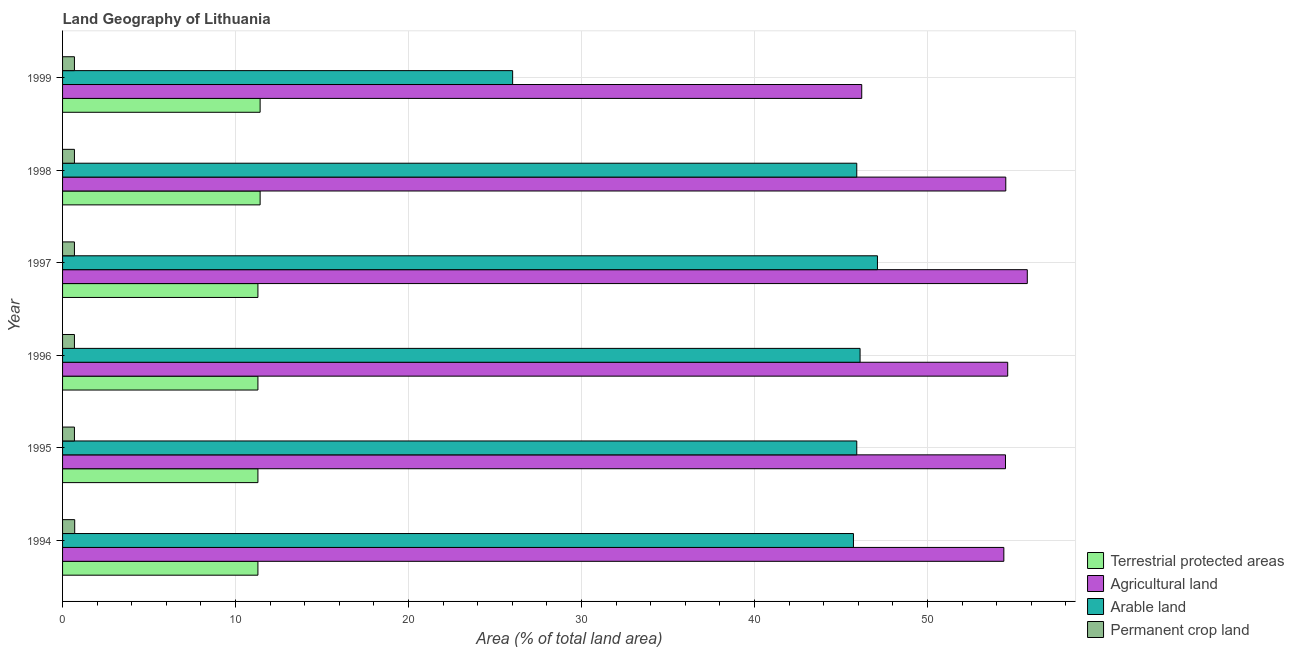How many groups of bars are there?
Offer a very short reply. 6. Are the number of bars on each tick of the Y-axis equal?
Your answer should be compact. Yes. What is the label of the 4th group of bars from the top?
Keep it short and to the point. 1996. In how many cases, is the number of bars for a given year not equal to the number of legend labels?
Ensure brevity in your answer.  0. What is the percentage of area under agricultural land in 1998?
Give a very brief answer. 54.53. Across all years, what is the maximum percentage of area under arable land?
Your answer should be compact. 47.11. Across all years, what is the minimum percentage of area under agricultural land?
Your response must be concise. 46.2. In which year was the percentage of area under permanent crop land maximum?
Keep it short and to the point. 1994. What is the total percentage of land under terrestrial protection in the graph?
Provide a succinct answer. 68.02. What is the difference between the percentage of area under agricultural land in 1997 and that in 1999?
Give a very brief answer. 9.57. What is the difference between the percentage of area under permanent crop land in 1995 and the percentage of area under agricultural land in 1999?
Make the answer very short. -45.52. What is the average percentage of area under agricultural land per year?
Offer a terse response. 53.35. In the year 1994, what is the difference between the percentage of area under permanent crop land and percentage of land under terrestrial protection?
Provide a succinct answer. -10.59. Is the difference between the percentage of land under terrestrial protection in 1995 and 1999 greater than the difference between the percentage of area under permanent crop land in 1995 and 1999?
Offer a very short reply. No. What is the difference between the highest and the second highest percentage of area under agricultural land?
Your answer should be very brief. 1.13. What is the difference between the highest and the lowest percentage of area under agricultural land?
Give a very brief answer. 9.57. Is it the case that in every year, the sum of the percentage of area under arable land and percentage of area under agricultural land is greater than the sum of percentage of land under terrestrial protection and percentage of area under permanent crop land?
Your answer should be very brief. Yes. What does the 3rd bar from the top in 1994 represents?
Your answer should be compact. Agricultural land. What does the 4th bar from the bottom in 1997 represents?
Provide a succinct answer. Permanent crop land. How many bars are there?
Provide a short and direct response. 24. Are all the bars in the graph horizontal?
Keep it short and to the point. Yes. What is the difference between two consecutive major ticks on the X-axis?
Provide a succinct answer. 10. Does the graph contain any zero values?
Your answer should be very brief. No. How many legend labels are there?
Provide a succinct answer. 4. What is the title of the graph?
Provide a short and direct response. Land Geography of Lithuania. Does "Primary education" appear as one of the legend labels in the graph?
Provide a short and direct response. No. What is the label or title of the X-axis?
Your answer should be compact. Area (% of total land area). What is the Area (% of total land area) in Terrestrial protected areas in 1994?
Offer a very short reply. 11.29. What is the Area (% of total land area) of Agricultural land in 1994?
Provide a succinct answer. 54.42. What is the Area (% of total land area) in Arable land in 1994?
Make the answer very short. 45.72. What is the Area (% of total land area) of Permanent crop land in 1994?
Keep it short and to the point. 0.7. What is the Area (% of total land area) of Terrestrial protected areas in 1995?
Provide a succinct answer. 11.29. What is the Area (% of total land area) in Agricultural land in 1995?
Provide a short and direct response. 54.51. What is the Area (% of total land area) in Arable land in 1995?
Provide a succinct answer. 45.92. What is the Area (% of total land area) in Permanent crop land in 1995?
Ensure brevity in your answer.  0.69. What is the Area (% of total land area) in Terrestrial protected areas in 1996?
Your answer should be compact. 11.29. What is the Area (% of total land area) in Agricultural land in 1996?
Your answer should be very brief. 54.64. What is the Area (% of total land area) in Arable land in 1996?
Give a very brief answer. 46.11. What is the Area (% of total land area) of Permanent crop land in 1996?
Provide a succinct answer. 0.69. What is the Area (% of total land area) of Terrestrial protected areas in 1997?
Give a very brief answer. 11.29. What is the Area (% of total land area) in Agricultural land in 1997?
Provide a short and direct response. 55.78. What is the Area (% of total land area) of Arable land in 1997?
Your answer should be compact. 47.11. What is the Area (% of total land area) in Permanent crop land in 1997?
Your answer should be very brief. 0.69. What is the Area (% of total land area) of Terrestrial protected areas in 1998?
Your answer should be compact. 11.42. What is the Area (% of total land area) in Agricultural land in 1998?
Provide a short and direct response. 54.53. What is the Area (% of total land area) in Arable land in 1998?
Give a very brief answer. 45.92. What is the Area (% of total land area) of Permanent crop land in 1998?
Your response must be concise. 0.69. What is the Area (% of total land area) of Terrestrial protected areas in 1999?
Ensure brevity in your answer.  11.42. What is the Area (% of total land area) of Agricultural land in 1999?
Offer a terse response. 46.2. What is the Area (% of total land area) of Arable land in 1999?
Make the answer very short. 26.02. What is the Area (% of total land area) in Permanent crop land in 1999?
Provide a succinct answer. 0.69. Across all years, what is the maximum Area (% of total land area) of Terrestrial protected areas?
Give a very brief answer. 11.42. Across all years, what is the maximum Area (% of total land area) in Agricultural land?
Provide a succinct answer. 55.78. Across all years, what is the maximum Area (% of total land area) in Arable land?
Provide a short and direct response. 47.11. Across all years, what is the maximum Area (% of total land area) in Permanent crop land?
Ensure brevity in your answer.  0.7. Across all years, what is the minimum Area (% of total land area) in Terrestrial protected areas?
Make the answer very short. 11.29. Across all years, what is the minimum Area (% of total land area) of Agricultural land?
Your response must be concise. 46.2. Across all years, what is the minimum Area (% of total land area) of Arable land?
Keep it short and to the point. 26.02. Across all years, what is the minimum Area (% of total land area) in Permanent crop land?
Keep it short and to the point. 0.69. What is the total Area (% of total land area) in Terrestrial protected areas in the graph?
Ensure brevity in your answer.  68.02. What is the total Area (% of total land area) of Agricultural land in the graph?
Ensure brevity in your answer.  320.09. What is the total Area (% of total land area) of Arable land in the graph?
Ensure brevity in your answer.  256.8. What is the total Area (% of total land area) in Permanent crop land in the graph?
Provide a succinct answer. 4.13. What is the difference between the Area (% of total land area) of Agricultural land in 1994 and that in 1995?
Provide a succinct answer. -0.1. What is the difference between the Area (% of total land area) in Arable land in 1994 and that in 1995?
Provide a succinct answer. -0.19. What is the difference between the Area (% of total land area) of Permanent crop land in 1994 and that in 1995?
Offer a very short reply. 0.02. What is the difference between the Area (% of total land area) in Agricultural land in 1994 and that in 1996?
Make the answer very short. -0.22. What is the difference between the Area (% of total land area) in Arable land in 1994 and that in 1996?
Offer a very short reply. -0.38. What is the difference between the Area (% of total land area) of Permanent crop land in 1994 and that in 1996?
Ensure brevity in your answer.  0.02. What is the difference between the Area (% of total land area) in Agricultural land in 1994 and that in 1997?
Your answer should be compact. -1.36. What is the difference between the Area (% of total land area) in Arable land in 1994 and that in 1997?
Keep it short and to the point. -1.39. What is the difference between the Area (% of total land area) of Permanent crop land in 1994 and that in 1997?
Offer a very short reply. 0.02. What is the difference between the Area (% of total land area) in Terrestrial protected areas in 1994 and that in 1998?
Your answer should be very brief. -0.13. What is the difference between the Area (% of total land area) in Agricultural land in 1994 and that in 1998?
Give a very brief answer. -0.11. What is the difference between the Area (% of total land area) of Arable land in 1994 and that in 1998?
Offer a terse response. -0.19. What is the difference between the Area (% of total land area) in Permanent crop land in 1994 and that in 1998?
Give a very brief answer. 0.02. What is the difference between the Area (% of total land area) of Terrestrial protected areas in 1994 and that in 1999?
Ensure brevity in your answer.  -0.13. What is the difference between the Area (% of total land area) of Agricultural land in 1994 and that in 1999?
Offer a terse response. 8.22. What is the difference between the Area (% of total land area) in Arable land in 1994 and that in 1999?
Keep it short and to the point. 19.7. What is the difference between the Area (% of total land area) in Permanent crop land in 1994 and that in 1999?
Offer a very short reply. 0.02. What is the difference between the Area (% of total land area) in Agricultural land in 1995 and that in 1996?
Provide a short and direct response. -0.13. What is the difference between the Area (% of total land area) of Arable land in 1995 and that in 1996?
Give a very brief answer. -0.19. What is the difference between the Area (% of total land area) in Agricultural land in 1995 and that in 1997?
Make the answer very short. -1.26. What is the difference between the Area (% of total land area) in Arable land in 1995 and that in 1997?
Give a very brief answer. -1.2. What is the difference between the Area (% of total land area) in Terrestrial protected areas in 1995 and that in 1998?
Your answer should be very brief. -0.13. What is the difference between the Area (% of total land area) in Agricultural land in 1995 and that in 1998?
Give a very brief answer. -0.02. What is the difference between the Area (% of total land area) of Permanent crop land in 1995 and that in 1998?
Offer a very short reply. 0. What is the difference between the Area (% of total land area) of Terrestrial protected areas in 1995 and that in 1999?
Give a very brief answer. -0.13. What is the difference between the Area (% of total land area) in Agricultural land in 1995 and that in 1999?
Your answer should be compact. 8.31. What is the difference between the Area (% of total land area) of Arable land in 1995 and that in 1999?
Offer a terse response. 19.89. What is the difference between the Area (% of total land area) in Agricultural land in 1996 and that in 1997?
Your answer should be very brief. -1.13. What is the difference between the Area (% of total land area) in Arable land in 1996 and that in 1997?
Ensure brevity in your answer.  -1.01. What is the difference between the Area (% of total land area) of Permanent crop land in 1996 and that in 1997?
Offer a terse response. 0. What is the difference between the Area (% of total land area) of Terrestrial protected areas in 1996 and that in 1998?
Your answer should be very brief. -0.13. What is the difference between the Area (% of total land area) in Agricultural land in 1996 and that in 1998?
Offer a terse response. 0.11. What is the difference between the Area (% of total land area) of Arable land in 1996 and that in 1998?
Provide a short and direct response. 0.19. What is the difference between the Area (% of total land area) in Terrestrial protected areas in 1996 and that in 1999?
Ensure brevity in your answer.  -0.13. What is the difference between the Area (% of total land area) in Agricultural land in 1996 and that in 1999?
Your answer should be compact. 8.44. What is the difference between the Area (% of total land area) of Arable land in 1996 and that in 1999?
Your answer should be compact. 20.09. What is the difference between the Area (% of total land area) in Permanent crop land in 1996 and that in 1999?
Ensure brevity in your answer.  0. What is the difference between the Area (% of total land area) of Terrestrial protected areas in 1997 and that in 1998?
Provide a succinct answer. -0.13. What is the difference between the Area (% of total land area) in Agricultural land in 1997 and that in 1998?
Your answer should be very brief. 1.24. What is the difference between the Area (% of total land area) in Arable land in 1997 and that in 1998?
Provide a succinct answer. 1.2. What is the difference between the Area (% of total land area) in Terrestrial protected areas in 1997 and that in 1999?
Offer a very short reply. -0.13. What is the difference between the Area (% of total land area) of Agricultural land in 1997 and that in 1999?
Your answer should be very brief. 9.57. What is the difference between the Area (% of total land area) of Arable land in 1997 and that in 1999?
Provide a short and direct response. 21.09. What is the difference between the Area (% of total land area) in Permanent crop land in 1997 and that in 1999?
Offer a very short reply. 0. What is the difference between the Area (% of total land area) of Terrestrial protected areas in 1998 and that in 1999?
Ensure brevity in your answer.  -0. What is the difference between the Area (% of total land area) in Agricultural land in 1998 and that in 1999?
Provide a succinct answer. 8.33. What is the difference between the Area (% of total land area) of Arable land in 1998 and that in 1999?
Ensure brevity in your answer.  19.89. What is the difference between the Area (% of total land area) in Terrestrial protected areas in 1994 and the Area (% of total land area) in Agricultural land in 1995?
Your answer should be very brief. -43.22. What is the difference between the Area (% of total land area) in Terrestrial protected areas in 1994 and the Area (% of total land area) in Arable land in 1995?
Your answer should be compact. -34.62. What is the difference between the Area (% of total land area) of Terrestrial protected areas in 1994 and the Area (% of total land area) of Permanent crop land in 1995?
Offer a terse response. 10.61. What is the difference between the Area (% of total land area) of Agricultural land in 1994 and the Area (% of total land area) of Arable land in 1995?
Your answer should be compact. 8.5. What is the difference between the Area (% of total land area) in Agricultural land in 1994 and the Area (% of total land area) in Permanent crop land in 1995?
Ensure brevity in your answer.  53.73. What is the difference between the Area (% of total land area) in Arable land in 1994 and the Area (% of total land area) in Permanent crop land in 1995?
Your answer should be compact. 45.04. What is the difference between the Area (% of total land area) of Terrestrial protected areas in 1994 and the Area (% of total land area) of Agricultural land in 1996?
Ensure brevity in your answer.  -43.35. What is the difference between the Area (% of total land area) of Terrestrial protected areas in 1994 and the Area (% of total land area) of Arable land in 1996?
Your response must be concise. -34.81. What is the difference between the Area (% of total land area) in Terrestrial protected areas in 1994 and the Area (% of total land area) in Permanent crop land in 1996?
Ensure brevity in your answer.  10.61. What is the difference between the Area (% of total land area) in Agricultural land in 1994 and the Area (% of total land area) in Arable land in 1996?
Your answer should be very brief. 8.31. What is the difference between the Area (% of total land area) of Agricultural land in 1994 and the Area (% of total land area) of Permanent crop land in 1996?
Provide a short and direct response. 53.73. What is the difference between the Area (% of total land area) in Arable land in 1994 and the Area (% of total land area) in Permanent crop land in 1996?
Provide a short and direct response. 45.04. What is the difference between the Area (% of total land area) of Terrestrial protected areas in 1994 and the Area (% of total land area) of Agricultural land in 1997?
Ensure brevity in your answer.  -44.48. What is the difference between the Area (% of total land area) of Terrestrial protected areas in 1994 and the Area (% of total land area) of Arable land in 1997?
Offer a very short reply. -35.82. What is the difference between the Area (% of total land area) of Terrestrial protected areas in 1994 and the Area (% of total land area) of Permanent crop land in 1997?
Offer a terse response. 10.61. What is the difference between the Area (% of total land area) of Agricultural land in 1994 and the Area (% of total land area) of Arable land in 1997?
Your answer should be compact. 7.31. What is the difference between the Area (% of total land area) of Agricultural land in 1994 and the Area (% of total land area) of Permanent crop land in 1997?
Your answer should be compact. 53.73. What is the difference between the Area (% of total land area) of Arable land in 1994 and the Area (% of total land area) of Permanent crop land in 1997?
Make the answer very short. 45.04. What is the difference between the Area (% of total land area) of Terrestrial protected areas in 1994 and the Area (% of total land area) of Agricultural land in 1998?
Offer a very short reply. -43.24. What is the difference between the Area (% of total land area) of Terrestrial protected areas in 1994 and the Area (% of total land area) of Arable land in 1998?
Ensure brevity in your answer.  -34.62. What is the difference between the Area (% of total land area) of Terrestrial protected areas in 1994 and the Area (% of total land area) of Permanent crop land in 1998?
Your answer should be compact. 10.61. What is the difference between the Area (% of total land area) of Agricultural land in 1994 and the Area (% of total land area) of Arable land in 1998?
Your response must be concise. 8.5. What is the difference between the Area (% of total land area) of Agricultural land in 1994 and the Area (% of total land area) of Permanent crop land in 1998?
Provide a succinct answer. 53.73. What is the difference between the Area (% of total land area) of Arable land in 1994 and the Area (% of total land area) of Permanent crop land in 1998?
Your answer should be compact. 45.04. What is the difference between the Area (% of total land area) of Terrestrial protected areas in 1994 and the Area (% of total land area) of Agricultural land in 1999?
Provide a succinct answer. -34.91. What is the difference between the Area (% of total land area) in Terrestrial protected areas in 1994 and the Area (% of total land area) in Arable land in 1999?
Provide a succinct answer. -14.73. What is the difference between the Area (% of total land area) in Terrestrial protected areas in 1994 and the Area (% of total land area) in Permanent crop land in 1999?
Give a very brief answer. 10.61. What is the difference between the Area (% of total land area) of Agricultural land in 1994 and the Area (% of total land area) of Arable land in 1999?
Keep it short and to the point. 28.4. What is the difference between the Area (% of total land area) in Agricultural land in 1994 and the Area (% of total land area) in Permanent crop land in 1999?
Keep it short and to the point. 53.73. What is the difference between the Area (% of total land area) in Arable land in 1994 and the Area (% of total land area) in Permanent crop land in 1999?
Offer a terse response. 45.04. What is the difference between the Area (% of total land area) in Terrestrial protected areas in 1995 and the Area (% of total land area) in Agricultural land in 1996?
Your answer should be compact. -43.35. What is the difference between the Area (% of total land area) in Terrestrial protected areas in 1995 and the Area (% of total land area) in Arable land in 1996?
Your answer should be compact. -34.81. What is the difference between the Area (% of total land area) of Terrestrial protected areas in 1995 and the Area (% of total land area) of Permanent crop land in 1996?
Ensure brevity in your answer.  10.61. What is the difference between the Area (% of total land area) in Agricultural land in 1995 and the Area (% of total land area) in Arable land in 1996?
Ensure brevity in your answer.  8.41. What is the difference between the Area (% of total land area) of Agricultural land in 1995 and the Area (% of total land area) of Permanent crop land in 1996?
Your answer should be very brief. 53.83. What is the difference between the Area (% of total land area) in Arable land in 1995 and the Area (% of total land area) in Permanent crop land in 1996?
Your answer should be very brief. 45.23. What is the difference between the Area (% of total land area) in Terrestrial protected areas in 1995 and the Area (% of total land area) in Agricultural land in 1997?
Give a very brief answer. -44.48. What is the difference between the Area (% of total land area) of Terrestrial protected areas in 1995 and the Area (% of total land area) of Arable land in 1997?
Provide a succinct answer. -35.82. What is the difference between the Area (% of total land area) of Terrestrial protected areas in 1995 and the Area (% of total land area) of Permanent crop land in 1997?
Give a very brief answer. 10.61. What is the difference between the Area (% of total land area) in Agricultural land in 1995 and the Area (% of total land area) in Arable land in 1997?
Offer a terse response. 7.4. What is the difference between the Area (% of total land area) of Agricultural land in 1995 and the Area (% of total land area) of Permanent crop land in 1997?
Offer a very short reply. 53.83. What is the difference between the Area (% of total land area) of Arable land in 1995 and the Area (% of total land area) of Permanent crop land in 1997?
Provide a short and direct response. 45.23. What is the difference between the Area (% of total land area) of Terrestrial protected areas in 1995 and the Area (% of total land area) of Agricultural land in 1998?
Offer a terse response. -43.24. What is the difference between the Area (% of total land area) in Terrestrial protected areas in 1995 and the Area (% of total land area) in Arable land in 1998?
Offer a terse response. -34.62. What is the difference between the Area (% of total land area) of Terrestrial protected areas in 1995 and the Area (% of total land area) of Permanent crop land in 1998?
Ensure brevity in your answer.  10.61. What is the difference between the Area (% of total land area) in Agricultural land in 1995 and the Area (% of total land area) in Arable land in 1998?
Provide a succinct answer. 8.6. What is the difference between the Area (% of total land area) of Agricultural land in 1995 and the Area (% of total land area) of Permanent crop land in 1998?
Keep it short and to the point. 53.83. What is the difference between the Area (% of total land area) of Arable land in 1995 and the Area (% of total land area) of Permanent crop land in 1998?
Your answer should be compact. 45.23. What is the difference between the Area (% of total land area) of Terrestrial protected areas in 1995 and the Area (% of total land area) of Agricultural land in 1999?
Give a very brief answer. -34.91. What is the difference between the Area (% of total land area) of Terrestrial protected areas in 1995 and the Area (% of total land area) of Arable land in 1999?
Your response must be concise. -14.73. What is the difference between the Area (% of total land area) of Terrestrial protected areas in 1995 and the Area (% of total land area) of Permanent crop land in 1999?
Offer a very short reply. 10.61. What is the difference between the Area (% of total land area) in Agricultural land in 1995 and the Area (% of total land area) in Arable land in 1999?
Give a very brief answer. 28.49. What is the difference between the Area (% of total land area) of Agricultural land in 1995 and the Area (% of total land area) of Permanent crop land in 1999?
Keep it short and to the point. 53.83. What is the difference between the Area (% of total land area) in Arable land in 1995 and the Area (% of total land area) in Permanent crop land in 1999?
Offer a very short reply. 45.23. What is the difference between the Area (% of total land area) of Terrestrial protected areas in 1996 and the Area (% of total land area) of Agricultural land in 1997?
Your response must be concise. -44.48. What is the difference between the Area (% of total land area) of Terrestrial protected areas in 1996 and the Area (% of total land area) of Arable land in 1997?
Your answer should be very brief. -35.82. What is the difference between the Area (% of total land area) in Terrestrial protected areas in 1996 and the Area (% of total land area) in Permanent crop land in 1997?
Provide a succinct answer. 10.61. What is the difference between the Area (% of total land area) of Agricultural land in 1996 and the Area (% of total land area) of Arable land in 1997?
Your answer should be very brief. 7.53. What is the difference between the Area (% of total land area) of Agricultural land in 1996 and the Area (% of total land area) of Permanent crop land in 1997?
Keep it short and to the point. 53.96. What is the difference between the Area (% of total land area) of Arable land in 1996 and the Area (% of total land area) of Permanent crop land in 1997?
Your answer should be compact. 45.42. What is the difference between the Area (% of total land area) of Terrestrial protected areas in 1996 and the Area (% of total land area) of Agricultural land in 1998?
Keep it short and to the point. -43.24. What is the difference between the Area (% of total land area) of Terrestrial protected areas in 1996 and the Area (% of total land area) of Arable land in 1998?
Offer a very short reply. -34.62. What is the difference between the Area (% of total land area) in Terrestrial protected areas in 1996 and the Area (% of total land area) in Permanent crop land in 1998?
Provide a succinct answer. 10.61. What is the difference between the Area (% of total land area) in Agricultural land in 1996 and the Area (% of total land area) in Arable land in 1998?
Make the answer very short. 8.73. What is the difference between the Area (% of total land area) in Agricultural land in 1996 and the Area (% of total land area) in Permanent crop land in 1998?
Offer a very short reply. 53.96. What is the difference between the Area (% of total land area) in Arable land in 1996 and the Area (% of total land area) in Permanent crop land in 1998?
Ensure brevity in your answer.  45.42. What is the difference between the Area (% of total land area) of Terrestrial protected areas in 1996 and the Area (% of total land area) of Agricultural land in 1999?
Make the answer very short. -34.91. What is the difference between the Area (% of total land area) of Terrestrial protected areas in 1996 and the Area (% of total land area) of Arable land in 1999?
Provide a short and direct response. -14.73. What is the difference between the Area (% of total land area) of Terrestrial protected areas in 1996 and the Area (% of total land area) of Permanent crop land in 1999?
Your response must be concise. 10.61. What is the difference between the Area (% of total land area) in Agricultural land in 1996 and the Area (% of total land area) in Arable land in 1999?
Provide a short and direct response. 28.62. What is the difference between the Area (% of total land area) of Agricultural land in 1996 and the Area (% of total land area) of Permanent crop land in 1999?
Offer a very short reply. 53.96. What is the difference between the Area (% of total land area) of Arable land in 1996 and the Area (% of total land area) of Permanent crop land in 1999?
Your answer should be compact. 45.42. What is the difference between the Area (% of total land area) of Terrestrial protected areas in 1997 and the Area (% of total land area) of Agricultural land in 1998?
Give a very brief answer. -43.24. What is the difference between the Area (% of total land area) of Terrestrial protected areas in 1997 and the Area (% of total land area) of Arable land in 1998?
Your answer should be very brief. -34.62. What is the difference between the Area (% of total land area) of Terrestrial protected areas in 1997 and the Area (% of total land area) of Permanent crop land in 1998?
Provide a succinct answer. 10.61. What is the difference between the Area (% of total land area) in Agricultural land in 1997 and the Area (% of total land area) in Arable land in 1998?
Your answer should be compact. 9.86. What is the difference between the Area (% of total land area) of Agricultural land in 1997 and the Area (% of total land area) of Permanent crop land in 1998?
Give a very brief answer. 55.09. What is the difference between the Area (% of total land area) of Arable land in 1997 and the Area (% of total land area) of Permanent crop land in 1998?
Your answer should be very brief. 46.43. What is the difference between the Area (% of total land area) of Terrestrial protected areas in 1997 and the Area (% of total land area) of Agricultural land in 1999?
Give a very brief answer. -34.91. What is the difference between the Area (% of total land area) of Terrestrial protected areas in 1997 and the Area (% of total land area) of Arable land in 1999?
Your answer should be compact. -14.73. What is the difference between the Area (% of total land area) of Terrestrial protected areas in 1997 and the Area (% of total land area) of Permanent crop land in 1999?
Make the answer very short. 10.61. What is the difference between the Area (% of total land area) of Agricultural land in 1997 and the Area (% of total land area) of Arable land in 1999?
Your response must be concise. 29.75. What is the difference between the Area (% of total land area) of Agricultural land in 1997 and the Area (% of total land area) of Permanent crop land in 1999?
Your answer should be compact. 55.09. What is the difference between the Area (% of total land area) of Arable land in 1997 and the Area (% of total land area) of Permanent crop land in 1999?
Your answer should be very brief. 46.43. What is the difference between the Area (% of total land area) of Terrestrial protected areas in 1998 and the Area (% of total land area) of Agricultural land in 1999?
Give a very brief answer. -34.78. What is the difference between the Area (% of total land area) of Terrestrial protected areas in 1998 and the Area (% of total land area) of Arable land in 1999?
Ensure brevity in your answer.  -14.6. What is the difference between the Area (% of total land area) in Terrestrial protected areas in 1998 and the Area (% of total land area) in Permanent crop land in 1999?
Your answer should be compact. 10.74. What is the difference between the Area (% of total land area) in Agricultural land in 1998 and the Area (% of total land area) in Arable land in 1999?
Your answer should be very brief. 28.51. What is the difference between the Area (% of total land area) in Agricultural land in 1998 and the Area (% of total land area) in Permanent crop land in 1999?
Your answer should be very brief. 53.84. What is the difference between the Area (% of total land area) of Arable land in 1998 and the Area (% of total land area) of Permanent crop land in 1999?
Your answer should be compact. 45.23. What is the average Area (% of total land area) of Terrestrial protected areas per year?
Provide a short and direct response. 11.34. What is the average Area (% of total land area) in Agricultural land per year?
Make the answer very short. 53.35. What is the average Area (% of total land area) in Arable land per year?
Offer a very short reply. 42.8. What is the average Area (% of total land area) of Permanent crop land per year?
Offer a terse response. 0.69. In the year 1994, what is the difference between the Area (% of total land area) in Terrestrial protected areas and Area (% of total land area) in Agricultural land?
Make the answer very short. -43.12. In the year 1994, what is the difference between the Area (% of total land area) in Terrestrial protected areas and Area (% of total land area) in Arable land?
Offer a terse response. -34.43. In the year 1994, what is the difference between the Area (% of total land area) of Terrestrial protected areas and Area (% of total land area) of Permanent crop land?
Your answer should be very brief. 10.59. In the year 1994, what is the difference between the Area (% of total land area) of Agricultural land and Area (% of total land area) of Arable land?
Make the answer very short. 8.7. In the year 1994, what is the difference between the Area (% of total land area) of Agricultural land and Area (% of total land area) of Permanent crop land?
Your answer should be very brief. 53.72. In the year 1994, what is the difference between the Area (% of total land area) of Arable land and Area (% of total land area) of Permanent crop land?
Offer a terse response. 45.02. In the year 1995, what is the difference between the Area (% of total land area) of Terrestrial protected areas and Area (% of total land area) of Agricultural land?
Keep it short and to the point. -43.22. In the year 1995, what is the difference between the Area (% of total land area) of Terrestrial protected areas and Area (% of total land area) of Arable land?
Your answer should be compact. -34.62. In the year 1995, what is the difference between the Area (% of total land area) of Terrestrial protected areas and Area (% of total land area) of Permanent crop land?
Your answer should be compact. 10.61. In the year 1995, what is the difference between the Area (% of total land area) in Agricultural land and Area (% of total land area) in Arable land?
Provide a short and direct response. 8.6. In the year 1995, what is the difference between the Area (% of total land area) of Agricultural land and Area (% of total land area) of Permanent crop land?
Your answer should be very brief. 53.83. In the year 1995, what is the difference between the Area (% of total land area) of Arable land and Area (% of total land area) of Permanent crop land?
Your response must be concise. 45.23. In the year 1996, what is the difference between the Area (% of total land area) in Terrestrial protected areas and Area (% of total land area) in Agricultural land?
Give a very brief answer. -43.35. In the year 1996, what is the difference between the Area (% of total land area) of Terrestrial protected areas and Area (% of total land area) of Arable land?
Your response must be concise. -34.81. In the year 1996, what is the difference between the Area (% of total land area) of Terrestrial protected areas and Area (% of total land area) of Permanent crop land?
Your answer should be compact. 10.61. In the year 1996, what is the difference between the Area (% of total land area) of Agricultural land and Area (% of total land area) of Arable land?
Provide a short and direct response. 8.54. In the year 1996, what is the difference between the Area (% of total land area) in Agricultural land and Area (% of total land area) in Permanent crop land?
Offer a very short reply. 53.96. In the year 1996, what is the difference between the Area (% of total land area) in Arable land and Area (% of total land area) in Permanent crop land?
Your answer should be very brief. 45.42. In the year 1997, what is the difference between the Area (% of total land area) in Terrestrial protected areas and Area (% of total land area) in Agricultural land?
Keep it short and to the point. -44.48. In the year 1997, what is the difference between the Area (% of total land area) in Terrestrial protected areas and Area (% of total land area) in Arable land?
Offer a terse response. -35.82. In the year 1997, what is the difference between the Area (% of total land area) in Terrestrial protected areas and Area (% of total land area) in Permanent crop land?
Your answer should be compact. 10.61. In the year 1997, what is the difference between the Area (% of total land area) in Agricultural land and Area (% of total land area) in Arable land?
Keep it short and to the point. 8.66. In the year 1997, what is the difference between the Area (% of total land area) of Agricultural land and Area (% of total land area) of Permanent crop land?
Offer a very short reply. 55.09. In the year 1997, what is the difference between the Area (% of total land area) in Arable land and Area (% of total land area) in Permanent crop land?
Offer a terse response. 46.43. In the year 1998, what is the difference between the Area (% of total land area) in Terrestrial protected areas and Area (% of total land area) in Agricultural land?
Offer a very short reply. -43.11. In the year 1998, what is the difference between the Area (% of total land area) of Terrestrial protected areas and Area (% of total land area) of Arable land?
Ensure brevity in your answer.  -34.49. In the year 1998, what is the difference between the Area (% of total land area) in Terrestrial protected areas and Area (% of total land area) in Permanent crop land?
Give a very brief answer. 10.74. In the year 1998, what is the difference between the Area (% of total land area) in Agricultural land and Area (% of total land area) in Arable land?
Your response must be concise. 8.62. In the year 1998, what is the difference between the Area (% of total land area) of Agricultural land and Area (% of total land area) of Permanent crop land?
Offer a very short reply. 53.84. In the year 1998, what is the difference between the Area (% of total land area) in Arable land and Area (% of total land area) in Permanent crop land?
Make the answer very short. 45.23. In the year 1999, what is the difference between the Area (% of total land area) of Terrestrial protected areas and Area (% of total land area) of Agricultural land?
Your answer should be compact. -34.78. In the year 1999, what is the difference between the Area (% of total land area) of Terrestrial protected areas and Area (% of total land area) of Arable land?
Your response must be concise. -14.6. In the year 1999, what is the difference between the Area (% of total land area) in Terrestrial protected areas and Area (% of total land area) in Permanent crop land?
Your response must be concise. 10.74. In the year 1999, what is the difference between the Area (% of total land area) of Agricultural land and Area (% of total land area) of Arable land?
Your response must be concise. 20.18. In the year 1999, what is the difference between the Area (% of total land area) of Agricultural land and Area (% of total land area) of Permanent crop land?
Provide a succinct answer. 45.52. In the year 1999, what is the difference between the Area (% of total land area) of Arable land and Area (% of total land area) of Permanent crop land?
Offer a very short reply. 25.34. What is the ratio of the Area (% of total land area) of Permanent crop land in 1994 to that in 1995?
Provide a succinct answer. 1.02. What is the ratio of the Area (% of total land area) of Permanent crop land in 1994 to that in 1996?
Your response must be concise. 1.02. What is the ratio of the Area (% of total land area) in Terrestrial protected areas in 1994 to that in 1997?
Keep it short and to the point. 1. What is the ratio of the Area (% of total land area) of Agricultural land in 1994 to that in 1997?
Your answer should be very brief. 0.98. What is the ratio of the Area (% of total land area) of Arable land in 1994 to that in 1997?
Give a very brief answer. 0.97. What is the ratio of the Area (% of total land area) in Permanent crop land in 1994 to that in 1997?
Offer a terse response. 1.02. What is the ratio of the Area (% of total land area) in Terrestrial protected areas in 1994 to that in 1998?
Your answer should be very brief. 0.99. What is the ratio of the Area (% of total land area) in Agricultural land in 1994 to that in 1998?
Your response must be concise. 1. What is the ratio of the Area (% of total land area) of Permanent crop land in 1994 to that in 1998?
Provide a succinct answer. 1.02. What is the ratio of the Area (% of total land area) of Agricultural land in 1994 to that in 1999?
Make the answer very short. 1.18. What is the ratio of the Area (% of total land area) of Arable land in 1994 to that in 1999?
Your answer should be compact. 1.76. What is the ratio of the Area (% of total land area) of Permanent crop land in 1994 to that in 1999?
Your response must be concise. 1.02. What is the ratio of the Area (% of total land area) of Terrestrial protected areas in 1995 to that in 1996?
Ensure brevity in your answer.  1. What is the ratio of the Area (% of total land area) of Permanent crop land in 1995 to that in 1996?
Offer a very short reply. 1. What is the ratio of the Area (% of total land area) in Terrestrial protected areas in 1995 to that in 1997?
Your answer should be compact. 1. What is the ratio of the Area (% of total land area) of Agricultural land in 1995 to that in 1997?
Your answer should be very brief. 0.98. What is the ratio of the Area (% of total land area) of Arable land in 1995 to that in 1997?
Your response must be concise. 0.97. What is the ratio of the Area (% of total land area) in Permanent crop land in 1995 to that in 1997?
Offer a terse response. 1. What is the ratio of the Area (% of total land area) of Terrestrial protected areas in 1995 to that in 1998?
Your response must be concise. 0.99. What is the ratio of the Area (% of total land area) in Agricultural land in 1995 to that in 1999?
Keep it short and to the point. 1.18. What is the ratio of the Area (% of total land area) in Arable land in 1995 to that in 1999?
Keep it short and to the point. 1.76. What is the ratio of the Area (% of total land area) in Permanent crop land in 1995 to that in 1999?
Your response must be concise. 1. What is the ratio of the Area (% of total land area) of Agricultural land in 1996 to that in 1997?
Offer a very short reply. 0.98. What is the ratio of the Area (% of total land area) in Arable land in 1996 to that in 1997?
Provide a short and direct response. 0.98. What is the ratio of the Area (% of total land area) in Terrestrial protected areas in 1996 to that in 1998?
Ensure brevity in your answer.  0.99. What is the ratio of the Area (% of total land area) of Agricultural land in 1996 to that in 1998?
Provide a succinct answer. 1. What is the ratio of the Area (% of total land area) in Permanent crop land in 1996 to that in 1998?
Provide a succinct answer. 1. What is the ratio of the Area (% of total land area) in Terrestrial protected areas in 1996 to that in 1999?
Ensure brevity in your answer.  0.99. What is the ratio of the Area (% of total land area) in Agricultural land in 1996 to that in 1999?
Provide a succinct answer. 1.18. What is the ratio of the Area (% of total land area) in Arable land in 1996 to that in 1999?
Your answer should be very brief. 1.77. What is the ratio of the Area (% of total land area) of Terrestrial protected areas in 1997 to that in 1998?
Give a very brief answer. 0.99. What is the ratio of the Area (% of total land area) in Agricultural land in 1997 to that in 1998?
Give a very brief answer. 1.02. What is the ratio of the Area (% of total land area) in Arable land in 1997 to that in 1998?
Provide a short and direct response. 1.03. What is the ratio of the Area (% of total land area) in Terrestrial protected areas in 1997 to that in 1999?
Provide a short and direct response. 0.99. What is the ratio of the Area (% of total land area) of Agricultural land in 1997 to that in 1999?
Your answer should be compact. 1.21. What is the ratio of the Area (% of total land area) in Arable land in 1997 to that in 1999?
Offer a very short reply. 1.81. What is the ratio of the Area (% of total land area) of Permanent crop land in 1997 to that in 1999?
Provide a short and direct response. 1. What is the ratio of the Area (% of total land area) of Terrestrial protected areas in 1998 to that in 1999?
Offer a very short reply. 1. What is the ratio of the Area (% of total land area) of Agricultural land in 1998 to that in 1999?
Provide a short and direct response. 1.18. What is the ratio of the Area (% of total land area) in Arable land in 1998 to that in 1999?
Give a very brief answer. 1.76. What is the ratio of the Area (% of total land area) in Permanent crop land in 1998 to that in 1999?
Ensure brevity in your answer.  1. What is the difference between the highest and the second highest Area (% of total land area) in Terrestrial protected areas?
Provide a succinct answer. 0. What is the difference between the highest and the second highest Area (% of total land area) in Agricultural land?
Your response must be concise. 1.13. What is the difference between the highest and the second highest Area (% of total land area) in Arable land?
Offer a terse response. 1.01. What is the difference between the highest and the second highest Area (% of total land area) of Permanent crop land?
Keep it short and to the point. 0.02. What is the difference between the highest and the lowest Area (% of total land area) of Terrestrial protected areas?
Your response must be concise. 0.13. What is the difference between the highest and the lowest Area (% of total land area) of Agricultural land?
Your answer should be compact. 9.57. What is the difference between the highest and the lowest Area (% of total land area) of Arable land?
Provide a succinct answer. 21.09. What is the difference between the highest and the lowest Area (% of total land area) in Permanent crop land?
Provide a short and direct response. 0.02. 